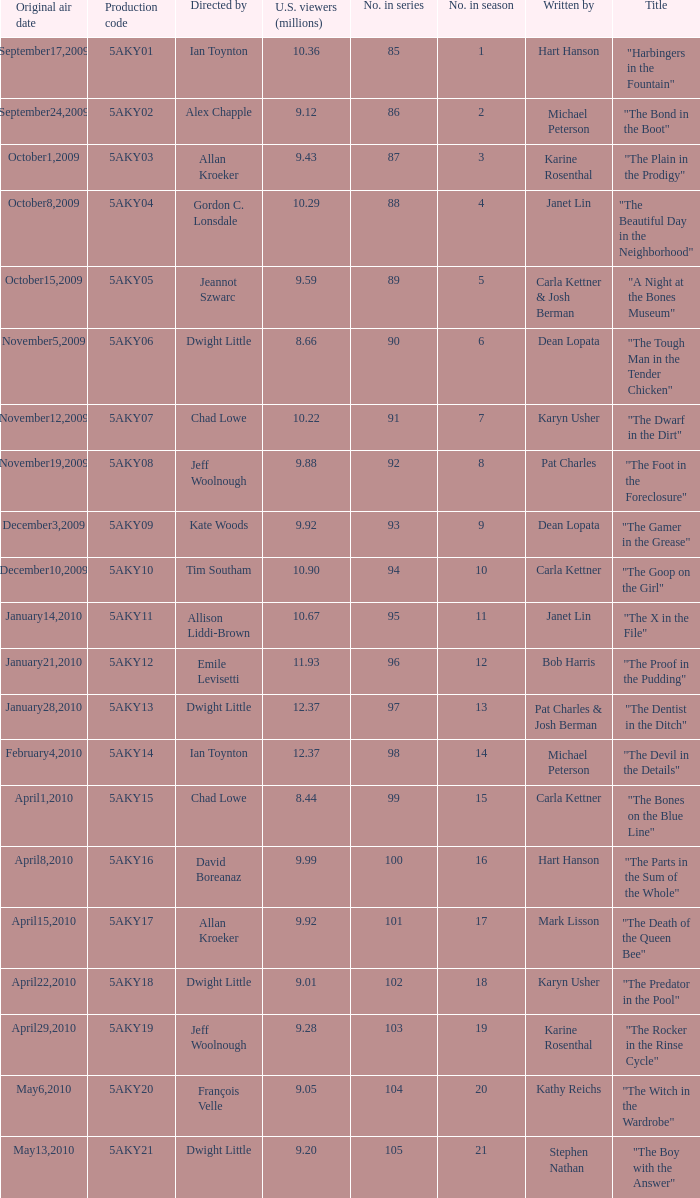What was the air date of the episode that has a production code of 5aky13? January28,2010. 